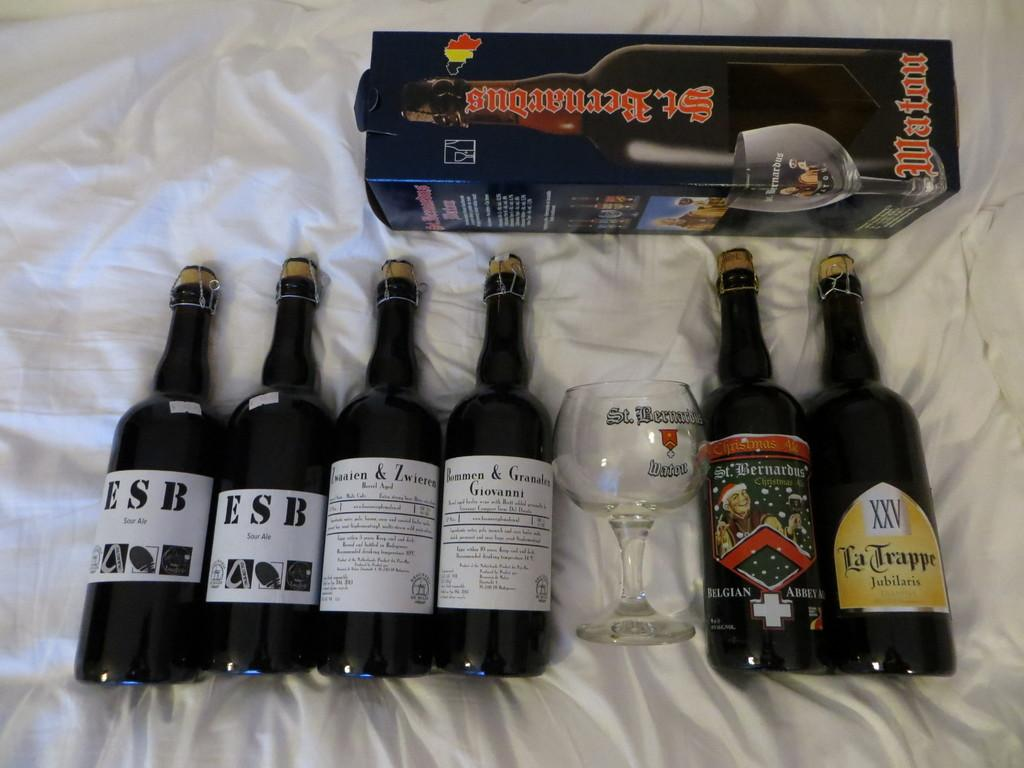Provide a one-sentence caption for the provided image. Two bottles of ESB sour ale sit next to some other alcohol bottles. 